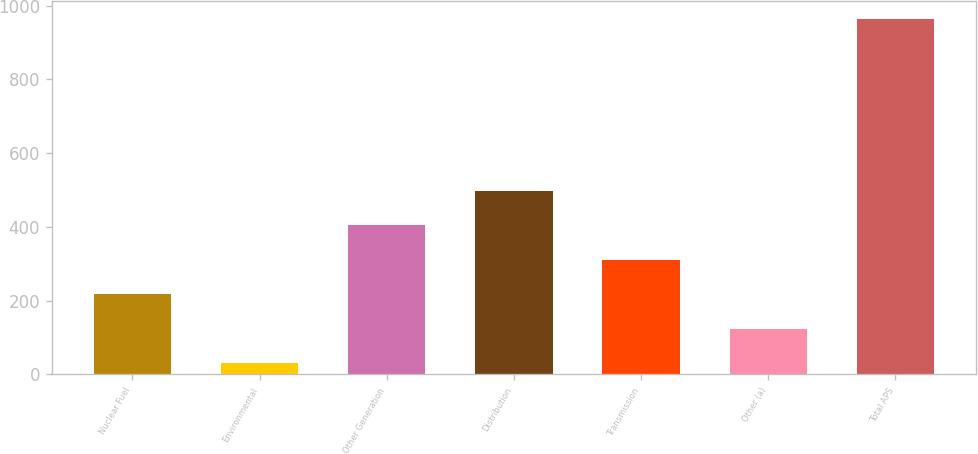Convert chart to OTSL. <chart><loc_0><loc_0><loc_500><loc_500><bar_chart><fcel>Nuclear Fuel<fcel>Environmental<fcel>Other Generation<fcel>Distribution<fcel>Transmission<fcel>Other (a)<fcel>Total APS<nl><fcel>217<fcel>30<fcel>404<fcel>497.5<fcel>310.5<fcel>123.5<fcel>965<nl></chart> 